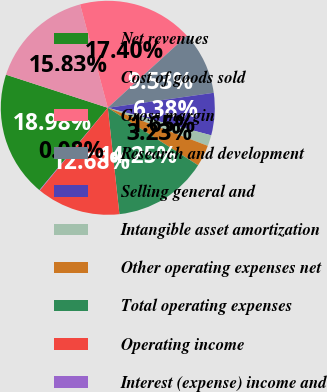<chart> <loc_0><loc_0><loc_500><loc_500><pie_chart><fcel>Net revenues<fcel>Cost of goods sold<fcel>Gross margin<fcel>Research and development<fcel>Selling general and<fcel>Intangible asset amortization<fcel>Other operating expenses net<fcel>Total operating expenses<fcel>Operating income<fcel>Interest (expense) income and<nl><fcel>18.98%<fcel>15.83%<fcel>17.4%<fcel>9.53%<fcel>6.38%<fcel>1.65%<fcel>3.23%<fcel>14.25%<fcel>12.68%<fcel>0.08%<nl></chart> 